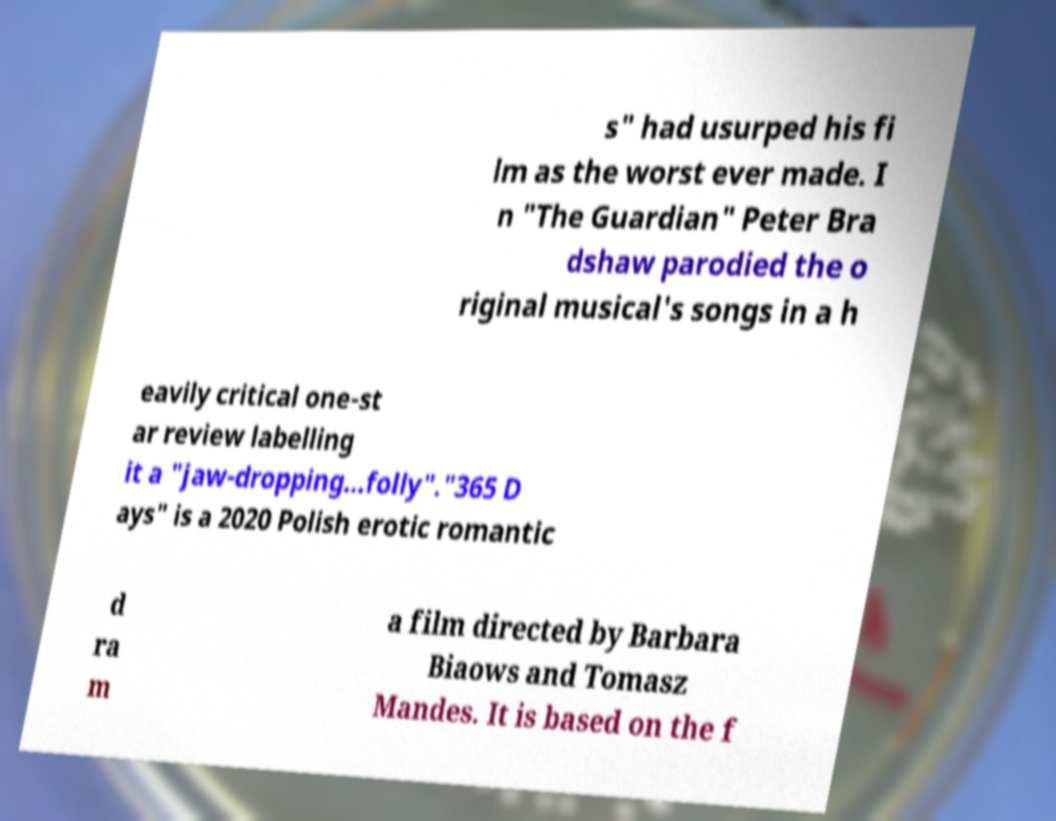What messages or text are displayed in this image? I need them in a readable, typed format. s" had usurped his fi lm as the worst ever made. I n "The Guardian" Peter Bra dshaw parodied the o riginal musical's songs in a h eavily critical one-st ar review labelling it a "jaw-dropping...folly"."365 D ays" is a 2020 Polish erotic romantic d ra m a film directed by Barbara Biaows and Tomasz Mandes. It is based on the f 